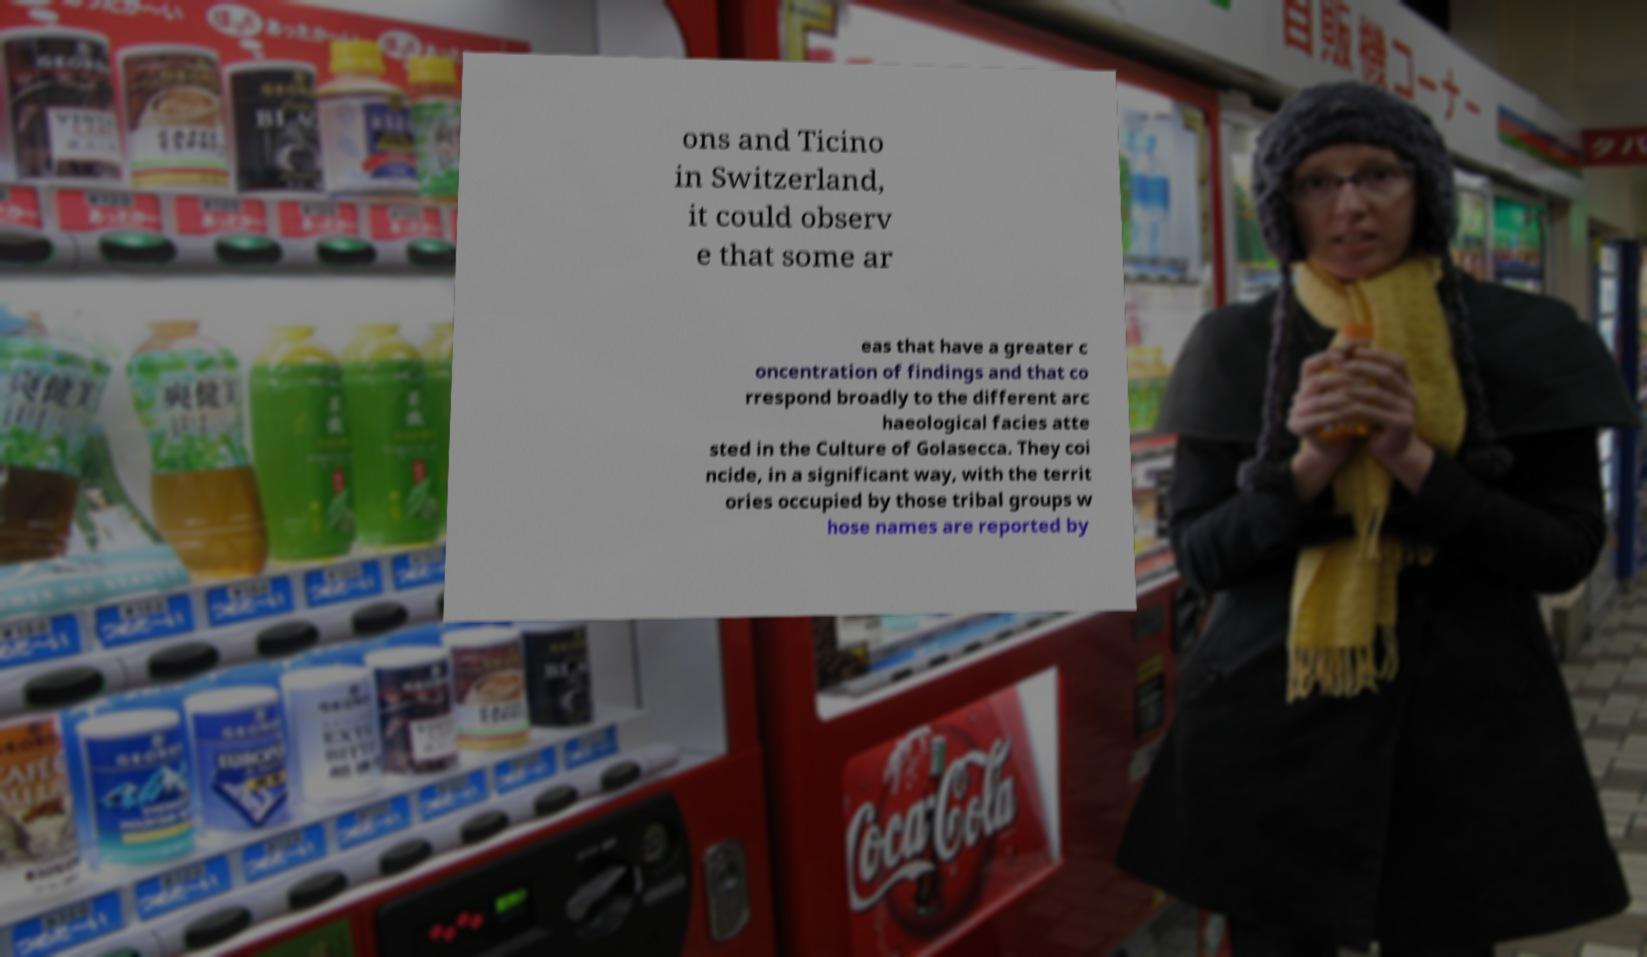Can you read and provide the text displayed in the image?This photo seems to have some interesting text. Can you extract and type it out for me? ons and Ticino in Switzerland, it could observ e that some ar eas that have a greater c oncentration of findings and that co rrespond broadly to the different arc haeological facies atte sted in the Culture of Golasecca. They coi ncide, in a significant way, with the territ ories occupied by those tribal groups w hose names are reported by 